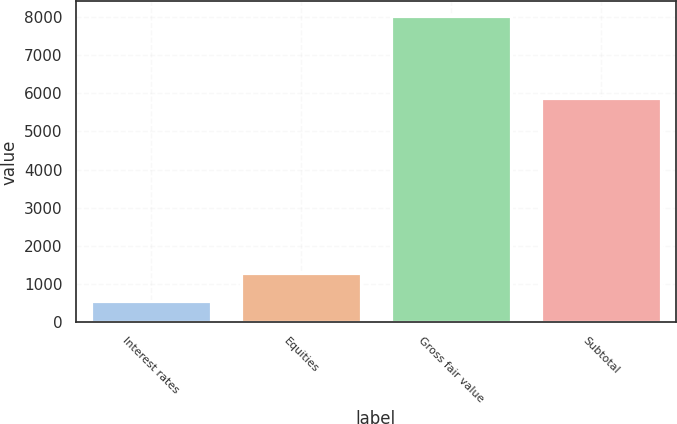Convert chart to OTSL. <chart><loc_0><loc_0><loc_500><loc_500><bar_chart><fcel>Interest rates<fcel>Equities<fcel>Gross fair value<fcel>Subtotal<nl><fcel>560<fcel>1304.9<fcel>8009<fcel>5870<nl></chart> 